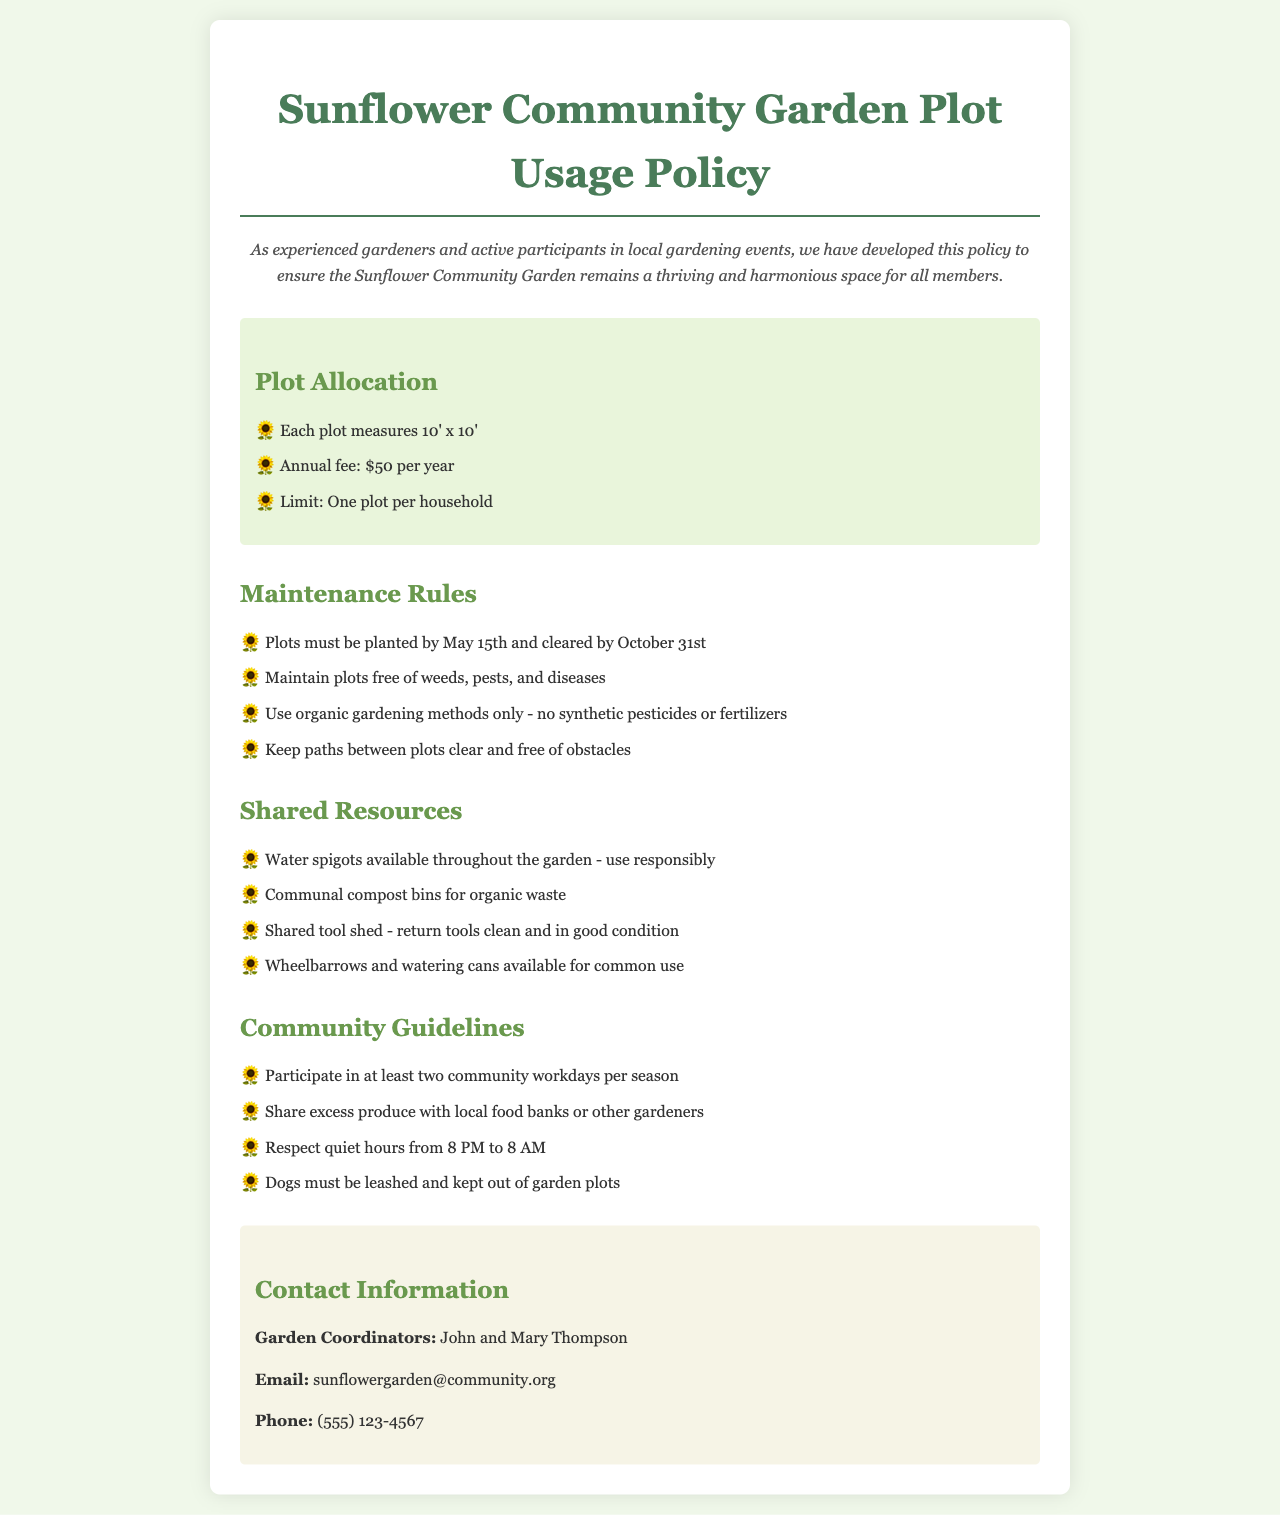What is the size of each plot? Each plot measures 10' x 10'.
Answer: 10' x 10' What is the annual fee for a garden plot? The document states the annual fee for a plot is $50 per year.
Answer: $50 By what date must plots be planted? The policy specifies that plots must be planted by May 15th.
Answer: May 15th What must gardeners use for maintenance? The maintenance rules require the use of organic gardening methods only.
Answer: organic gardening methods How many community workdays must a member participate in per season? The guidelines state that members must participate in at least two community workdays per season.
Answer: two What are the shared tools available for common use? The document mentions shared wheelbarrows and watering cans available for common use.
Answer: wheelbarrows and watering cans Who are the garden coordinators? The policy document lists John and Mary Thompson as the garden coordinators.
Answer: John and Mary Thompson What is the contact email for the garden coordinators? The document provides sunflowergarden@community.org as the email for the garden coordinators.
Answer: sunflowergarden@community.org 